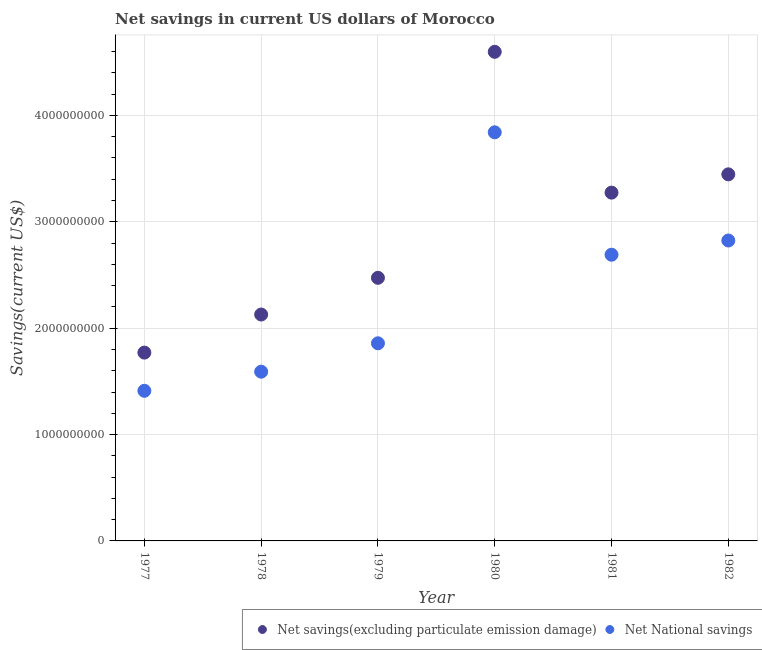What is the net savings(excluding particulate emission damage) in 1977?
Provide a short and direct response. 1.77e+09. Across all years, what is the maximum net savings(excluding particulate emission damage)?
Your answer should be very brief. 4.60e+09. Across all years, what is the minimum net national savings?
Ensure brevity in your answer.  1.41e+09. What is the total net national savings in the graph?
Your answer should be compact. 1.42e+1. What is the difference between the net national savings in 1979 and that in 1981?
Your response must be concise. -8.33e+08. What is the difference between the net savings(excluding particulate emission damage) in 1982 and the net national savings in 1978?
Ensure brevity in your answer.  1.86e+09. What is the average net national savings per year?
Offer a terse response. 2.37e+09. In the year 1982, what is the difference between the net national savings and net savings(excluding particulate emission damage)?
Offer a terse response. -6.22e+08. In how many years, is the net national savings greater than 2600000000 US$?
Your answer should be compact. 3. What is the ratio of the net national savings in 1979 to that in 1980?
Offer a very short reply. 0.48. Is the net savings(excluding particulate emission damage) in 1978 less than that in 1982?
Provide a short and direct response. Yes. Is the difference between the net savings(excluding particulate emission damage) in 1977 and 1980 greater than the difference between the net national savings in 1977 and 1980?
Your response must be concise. No. What is the difference between the highest and the second highest net national savings?
Offer a very short reply. 1.02e+09. What is the difference between the highest and the lowest net national savings?
Make the answer very short. 2.43e+09. In how many years, is the net national savings greater than the average net national savings taken over all years?
Offer a very short reply. 3. Does the net savings(excluding particulate emission damage) monotonically increase over the years?
Offer a terse response. No. Is the net savings(excluding particulate emission damage) strictly less than the net national savings over the years?
Your response must be concise. No. How many dotlines are there?
Provide a short and direct response. 2. What is the difference between two consecutive major ticks on the Y-axis?
Make the answer very short. 1.00e+09. How many legend labels are there?
Ensure brevity in your answer.  2. What is the title of the graph?
Ensure brevity in your answer.  Net savings in current US dollars of Morocco. Does "Rural Population" appear as one of the legend labels in the graph?
Ensure brevity in your answer.  No. What is the label or title of the X-axis?
Provide a succinct answer. Year. What is the label or title of the Y-axis?
Keep it short and to the point. Savings(current US$). What is the Savings(current US$) of Net savings(excluding particulate emission damage) in 1977?
Your response must be concise. 1.77e+09. What is the Savings(current US$) of Net National savings in 1977?
Keep it short and to the point. 1.41e+09. What is the Savings(current US$) in Net savings(excluding particulate emission damage) in 1978?
Provide a succinct answer. 2.13e+09. What is the Savings(current US$) of Net National savings in 1978?
Your answer should be compact. 1.59e+09. What is the Savings(current US$) of Net savings(excluding particulate emission damage) in 1979?
Make the answer very short. 2.47e+09. What is the Savings(current US$) in Net National savings in 1979?
Make the answer very short. 1.86e+09. What is the Savings(current US$) in Net savings(excluding particulate emission damage) in 1980?
Your answer should be compact. 4.60e+09. What is the Savings(current US$) of Net National savings in 1980?
Your answer should be very brief. 3.84e+09. What is the Savings(current US$) of Net savings(excluding particulate emission damage) in 1981?
Provide a succinct answer. 3.27e+09. What is the Savings(current US$) in Net National savings in 1981?
Offer a very short reply. 2.69e+09. What is the Savings(current US$) in Net savings(excluding particulate emission damage) in 1982?
Offer a terse response. 3.45e+09. What is the Savings(current US$) in Net National savings in 1982?
Make the answer very short. 2.82e+09. Across all years, what is the maximum Savings(current US$) in Net savings(excluding particulate emission damage)?
Offer a terse response. 4.60e+09. Across all years, what is the maximum Savings(current US$) of Net National savings?
Make the answer very short. 3.84e+09. Across all years, what is the minimum Savings(current US$) of Net savings(excluding particulate emission damage)?
Give a very brief answer. 1.77e+09. Across all years, what is the minimum Savings(current US$) of Net National savings?
Keep it short and to the point. 1.41e+09. What is the total Savings(current US$) in Net savings(excluding particulate emission damage) in the graph?
Keep it short and to the point. 1.77e+1. What is the total Savings(current US$) in Net National savings in the graph?
Offer a terse response. 1.42e+1. What is the difference between the Savings(current US$) of Net savings(excluding particulate emission damage) in 1977 and that in 1978?
Your response must be concise. -3.58e+08. What is the difference between the Savings(current US$) in Net National savings in 1977 and that in 1978?
Ensure brevity in your answer.  -1.80e+08. What is the difference between the Savings(current US$) of Net savings(excluding particulate emission damage) in 1977 and that in 1979?
Your response must be concise. -7.03e+08. What is the difference between the Savings(current US$) of Net National savings in 1977 and that in 1979?
Your answer should be very brief. -4.47e+08. What is the difference between the Savings(current US$) in Net savings(excluding particulate emission damage) in 1977 and that in 1980?
Provide a short and direct response. -2.83e+09. What is the difference between the Savings(current US$) of Net National savings in 1977 and that in 1980?
Your answer should be very brief. -2.43e+09. What is the difference between the Savings(current US$) in Net savings(excluding particulate emission damage) in 1977 and that in 1981?
Your response must be concise. -1.50e+09. What is the difference between the Savings(current US$) of Net National savings in 1977 and that in 1981?
Give a very brief answer. -1.28e+09. What is the difference between the Savings(current US$) in Net savings(excluding particulate emission damage) in 1977 and that in 1982?
Provide a short and direct response. -1.68e+09. What is the difference between the Savings(current US$) in Net National savings in 1977 and that in 1982?
Provide a short and direct response. -1.41e+09. What is the difference between the Savings(current US$) of Net savings(excluding particulate emission damage) in 1978 and that in 1979?
Provide a succinct answer. -3.45e+08. What is the difference between the Savings(current US$) of Net National savings in 1978 and that in 1979?
Offer a very short reply. -2.67e+08. What is the difference between the Savings(current US$) of Net savings(excluding particulate emission damage) in 1978 and that in 1980?
Offer a very short reply. -2.47e+09. What is the difference between the Savings(current US$) in Net National savings in 1978 and that in 1980?
Ensure brevity in your answer.  -2.25e+09. What is the difference between the Savings(current US$) of Net savings(excluding particulate emission damage) in 1978 and that in 1981?
Offer a terse response. -1.15e+09. What is the difference between the Savings(current US$) in Net National savings in 1978 and that in 1981?
Offer a very short reply. -1.10e+09. What is the difference between the Savings(current US$) of Net savings(excluding particulate emission damage) in 1978 and that in 1982?
Provide a short and direct response. -1.32e+09. What is the difference between the Savings(current US$) of Net National savings in 1978 and that in 1982?
Your answer should be very brief. -1.23e+09. What is the difference between the Savings(current US$) in Net savings(excluding particulate emission damage) in 1979 and that in 1980?
Your answer should be compact. -2.12e+09. What is the difference between the Savings(current US$) in Net National savings in 1979 and that in 1980?
Give a very brief answer. -1.98e+09. What is the difference between the Savings(current US$) of Net savings(excluding particulate emission damage) in 1979 and that in 1981?
Provide a succinct answer. -8.01e+08. What is the difference between the Savings(current US$) of Net National savings in 1979 and that in 1981?
Ensure brevity in your answer.  -8.33e+08. What is the difference between the Savings(current US$) in Net savings(excluding particulate emission damage) in 1979 and that in 1982?
Offer a terse response. -9.73e+08. What is the difference between the Savings(current US$) of Net National savings in 1979 and that in 1982?
Provide a short and direct response. -9.66e+08. What is the difference between the Savings(current US$) in Net savings(excluding particulate emission damage) in 1980 and that in 1981?
Your answer should be very brief. 1.32e+09. What is the difference between the Savings(current US$) of Net National savings in 1980 and that in 1981?
Ensure brevity in your answer.  1.15e+09. What is the difference between the Savings(current US$) of Net savings(excluding particulate emission damage) in 1980 and that in 1982?
Give a very brief answer. 1.15e+09. What is the difference between the Savings(current US$) of Net National savings in 1980 and that in 1982?
Keep it short and to the point. 1.02e+09. What is the difference between the Savings(current US$) of Net savings(excluding particulate emission damage) in 1981 and that in 1982?
Keep it short and to the point. -1.72e+08. What is the difference between the Savings(current US$) in Net National savings in 1981 and that in 1982?
Make the answer very short. -1.34e+08. What is the difference between the Savings(current US$) of Net savings(excluding particulate emission damage) in 1977 and the Savings(current US$) of Net National savings in 1978?
Your answer should be very brief. 1.79e+08. What is the difference between the Savings(current US$) of Net savings(excluding particulate emission damage) in 1977 and the Savings(current US$) of Net National savings in 1979?
Ensure brevity in your answer.  -8.75e+07. What is the difference between the Savings(current US$) of Net savings(excluding particulate emission damage) in 1977 and the Savings(current US$) of Net National savings in 1980?
Your answer should be very brief. -2.07e+09. What is the difference between the Savings(current US$) of Net savings(excluding particulate emission damage) in 1977 and the Savings(current US$) of Net National savings in 1981?
Provide a succinct answer. -9.20e+08. What is the difference between the Savings(current US$) of Net savings(excluding particulate emission damage) in 1977 and the Savings(current US$) of Net National savings in 1982?
Ensure brevity in your answer.  -1.05e+09. What is the difference between the Savings(current US$) in Net savings(excluding particulate emission damage) in 1978 and the Savings(current US$) in Net National savings in 1979?
Your answer should be compact. 2.71e+08. What is the difference between the Savings(current US$) in Net savings(excluding particulate emission damage) in 1978 and the Savings(current US$) in Net National savings in 1980?
Offer a terse response. -1.71e+09. What is the difference between the Savings(current US$) of Net savings(excluding particulate emission damage) in 1978 and the Savings(current US$) of Net National savings in 1981?
Provide a short and direct response. -5.62e+08. What is the difference between the Savings(current US$) of Net savings(excluding particulate emission damage) in 1978 and the Savings(current US$) of Net National savings in 1982?
Give a very brief answer. -6.96e+08. What is the difference between the Savings(current US$) of Net savings(excluding particulate emission damage) in 1979 and the Savings(current US$) of Net National savings in 1980?
Keep it short and to the point. -1.37e+09. What is the difference between the Savings(current US$) of Net savings(excluding particulate emission damage) in 1979 and the Savings(current US$) of Net National savings in 1981?
Give a very brief answer. -2.17e+08. What is the difference between the Savings(current US$) in Net savings(excluding particulate emission damage) in 1979 and the Savings(current US$) in Net National savings in 1982?
Provide a succinct answer. -3.51e+08. What is the difference between the Savings(current US$) of Net savings(excluding particulate emission damage) in 1980 and the Savings(current US$) of Net National savings in 1981?
Provide a succinct answer. 1.91e+09. What is the difference between the Savings(current US$) in Net savings(excluding particulate emission damage) in 1980 and the Savings(current US$) in Net National savings in 1982?
Offer a terse response. 1.77e+09. What is the difference between the Savings(current US$) in Net savings(excluding particulate emission damage) in 1981 and the Savings(current US$) in Net National savings in 1982?
Give a very brief answer. 4.50e+08. What is the average Savings(current US$) of Net savings(excluding particulate emission damage) per year?
Provide a short and direct response. 2.95e+09. What is the average Savings(current US$) of Net National savings per year?
Give a very brief answer. 2.37e+09. In the year 1977, what is the difference between the Savings(current US$) in Net savings(excluding particulate emission damage) and Savings(current US$) in Net National savings?
Ensure brevity in your answer.  3.59e+08. In the year 1978, what is the difference between the Savings(current US$) in Net savings(excluding particulate emission damage) and Savings(current US$) in Net National savings?
Give a very brief answer. 5.37e+08. In the year 1979, what is the difference between the Savings(current US$) in Net savings(excluding particulate emission damage) and Savings(current US$) in Net National savings?
Your answer should be very brief. 6.16e+08. In the year 1980, what is the difference between the Savings(current US$) of Net savings(excluding particulate emission damage) and Savings(current US$) of Net National savings?
Make the answer very short. 7.57e+08. In the year 1981, what is the difference between the Savings(current US$) in Net savings(excluding particulate emission damage) and Savings(current US$) in Net National savings?
Your answer should be compact. 5.84e+08. In the year 1982, what is the difference between the Savings(current US$) of Net savings(excluding particulate emission damage) and Savings(current US$) of Net National savings?
Offer a terse response. 6.22e+08. What is the ratio of the Savings(current US$) of Net savings(excluding particulate emission damage) in 1977 to that in 1978?
Provide a succinct answer. 0.83. What is the ratio of the Savings(current US$) of Net National savings in 1977 to that in 1978?
Keep it short and to the point. 0.89. What is the ratio of the Savings(current US$) in Net savings(excluding particulate emission damage) in 1977 to that in 1979?
Keep it short and to the point. 0.72. What is the ratio of the Savings(current US$) of Net National savings in 1977 to that in 1979?
Your response must be concise. 0.76. What is the ratio of the Savings(current US$) in Net savings(excluding particulate emission damage) in 1977 to that in 1980?
Provide a succinct answer. 0.39. What is the ratio of the Savings(current US$) in Net National savings in 1977 to that in 1980?
Offer a terse response. 0.37. What is the ratio of the Savings(current US$) in Net savings(excluding particulate emission damage) in 1977 to that in 1981?
Ensure brevity in your answer.  0.54. What is the ratio of the Savings(current US$) of Net National savings in 1977 to that in 1981?
Your answer should be compact. 0.52. What is the ratio of the Savings(current US$) in Net savings(excluding particulate emission damage) in 1977 to that in 1982?
Keep it short and to the point. 0.51. What is the ratio of the Savings(current US$) of Net National savings in 1977 to that in 1982?
Ensure brevity in your answer.  0.5. What is the ratio of the Savings(current US$) of Net savings(excluding particulate emission damage) in 1978 to that in 1979?
Keep it short and to the point. 0.86. What is the ratio of the Savings(current US$) in Net National savings in 1978 to that in 1979?
Your answer should be very brief. 0.86. What is the ratio of the Savings(current US$) of Net savings(excluding particulate emission damage) in 1978 to that in 1980?
Your response must be concise. 0.46. What is the ratio of the Savings(current US$) in Net National savings in 1978 to that in 1980?
Your response must be concise. 0.41. What is the ratio of the Savings(current US$) of Net savings(excluding particulate emission damage) in 1978 to that in 1981?
Make the answer very short. 0.65. What is the ratio of the Savings(current US$) of Net National savings in 1978 to that in 1981?
Keep it short and to the point. 0.59. What is the ratio of the Savings(current US$) in Net savings(excluding particulate emission damage) in 1978 to that in 1982?
Make the answer very short. 0.62. What is the ratio of the Savings(current US$) in Net National savings in 1978 to that in 1982?
Your response must be concise. 0.56. What is the ratio of the Savings(current US$) of Net savings(excluding particulate emission damage) in 1979 to that in 1980?
Ensure brevity in your answer.  0.54. What is the ratio of the Savings(current US$) in Net National savings in 1979 to that in 1980?
Ensure brevity in your answer.  0.48. What is the ratio of the Savings(current US$) in Net savings(excluding particulate emission damage) in 1979 to that in 1981?
Make the answer very short. 0.76. What is the ratio of the Savings(current US$) in Net National savings in 1979 to that in 1981?
Your response must be concise. 0.69. What is the ratio of the Savings(current US$) of Net savings(excluding particulate emission damage) in 1979 to that in 1982?
Provide a succinct answer. 0.72. What is the ratio of the Savings(current US$) in Net National savings in 1979 to that in 1982?
Give a very brief answer. 0.66. What is the ratio of the Savings(current US$) of Net savings(excluding particulate emission damage) in 1980 to that in 1981?
Ensure brevity in your answer.  1.4. What is the ratio of the Savings(current US$) in Net National savings in 1980 to that in 1981?
Offer a very short reply. 1.43. What is the ratio of the Savings(current US$) of Net savings(excluding particulate emission damage) in 1980 to that in 1982?
Provide a short and direct response. 1.33. What is the ratio of the Savings(current US$) of Net National savings in 1980 to that in 1982?
Your response must be concise. 1.36. What is the ratio of the Savings(current US$) of Net savings(excluding particulate emission damage) in 1981 to that in 1982?
Your answer should be compact. 0.95. What is the ratio of the Savings(current US$) in Net National savings in 1981 to that in 1982?
Your response must be concise. 0.95. What is the difference between the highest and the second highest Savings(current US$) of Net savings(excluding particulate emission damage)?
Make the answer very short. 1.15e+09. What is the difference between the highest and the second highest Savings(current US$) in Net National savings?
Your answer should be compact. 1.02e+09. What is the difference between the highest and the lowest Savings(current US$) in Net savings(excluding particulate emission damage)?
Your response must be concise. 2.83e+09. What is the difference between the highest and the lowest Savings(current US$) in Net National savings?
Offer a very short reply. 2.43e+09. 